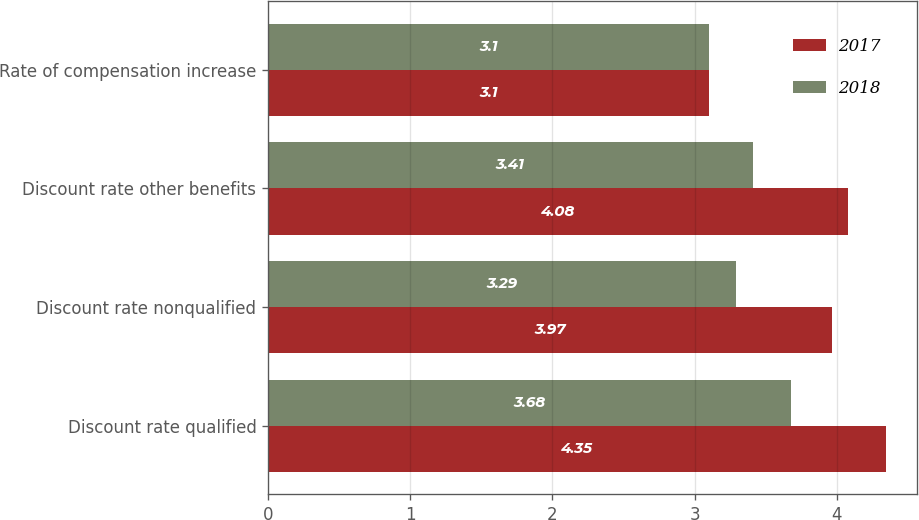<chart> <loc_0><loc_0><loc_500><loc_500><stacked_bar_chart><ecel><fcel>Discount rate qualified<fcel>Discount rate nonqualified<fcel>Discount rate other benefits<fcel>Rate of compensation increase<nl><fcel>2017<fcel>4.35<fcel>3.97<fcel>4.08<fcel>3.1<nl><fcel>2018<fcel>3.68<fcel>3.29<fcel>3.41<fcel>3.1<nl></chart> 